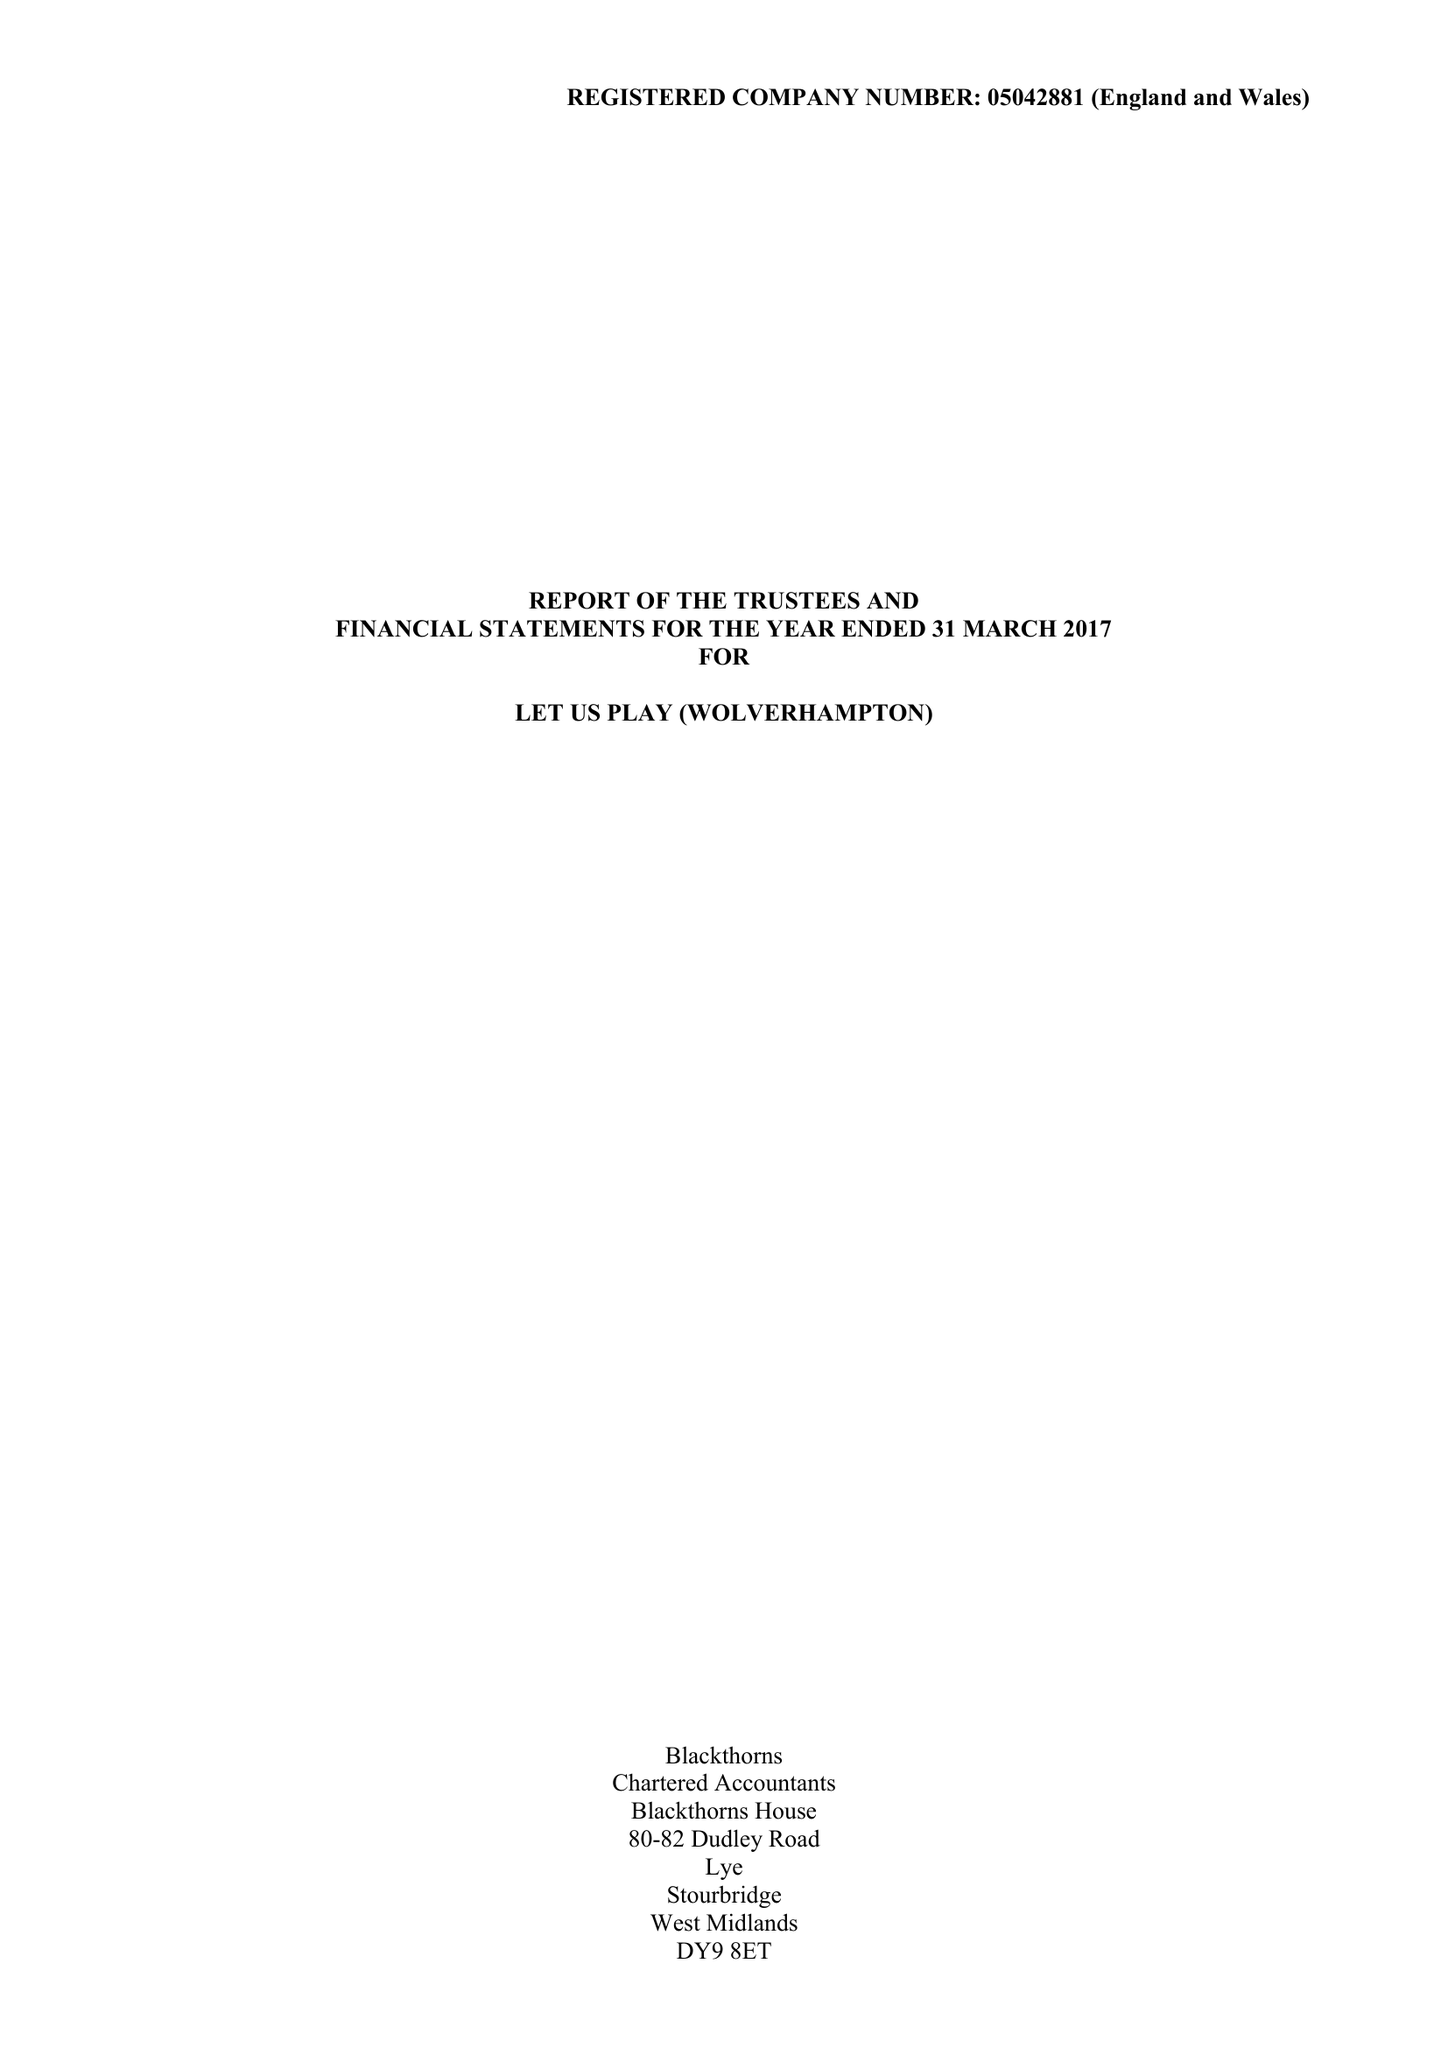What is the value for the address__post_town?
Answer the question using a single word or phrase. WOLVERHAMPTON 